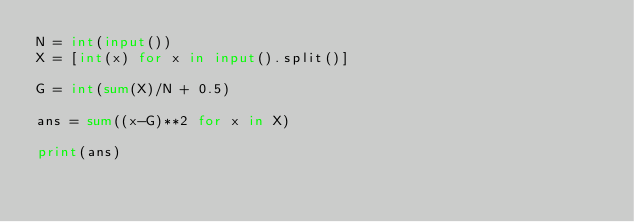Convert code to text. <code><loc_0><loc_0><loc_500><loc_500><_Python_>N = int(input())
X = [int(x) for x in input().split()]

G = int(sum(X)/N + 0.5)

ans = sum((x-G)**2 for x in X)

print(ans)</code> 